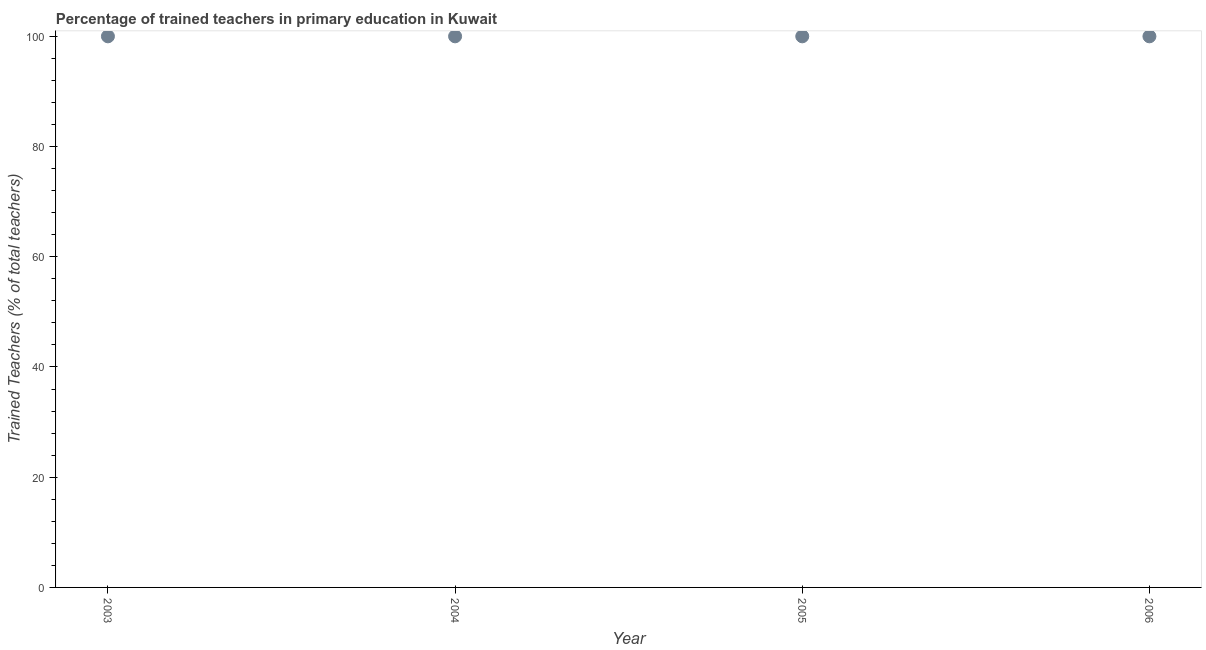Across all years, what is the minimum percentage of trained teachers?
Your answer should be very brief. 100. In which year was the percentage of trained teachers maximum?
Offer a very short reply. 2003. What is the average percentage of trained teachers per year?
Give a very brief answer. 100. What is the median percentage of trained teachers?
Offer a very short reply. 100. Do a majority of the years between 2006 and 2003 (inclusive) have percentage of trained teachers greater than 4 %?
Make the answer very short. Yes. Is the difference between the percentage of trained teachers in 2003 and 2006 greater than the difference between any two years?
Your answer should be compact. Yes. Is the sum of the percentage of trained teachers in 2003 and 2004 greater than the maximum percentage of trained teachers across all years?
Your response must be concise. Yes. How many years are there in the graph?
Your answer should be very brief. 4. What is the difference between two consecutive major ticks on the Y-axis?
Your answer should be very brief. 20. Does the graph contain grids?
Ensure brevity in your answer.  No. What is the title of the graph?
Your response must be concise. Percentage of trained teachers in primary education in Kuwait. What is the label or title of the X-axis?
Keep it short and to the point. Year. What is the label or title of the Y-axis?
Make the answer very short. Trained Teachers (% of total teachers). What is the Trained Teachers (% of total teachers) in 2003?
Your response must be concise. 100. What is the Trained Teachers (% of total teachers) in 2004?
Your answer should be very brief. 100. What is the Trained Teachers (% of total teachers) in 2006?
Your answer should be compact. 100. What is the difference between the Trained Teachers (% of total teachers) in 2005 and 2006?
Ensure brevity in your answer.  0. What is the ratio of the Trained Teachers (% of total teachers) in 2003 to that in 2004?
Ensure brevity in your answer.  1. What is the ratio of the Trained Teachers (% of total teachers) in 2003 to that in 2005?
Provide a succinct answer. 1. What is the ratio of the Trained Teachers (% of total teachers) in 2004 to that in 2005?
Make the answer very short. 1. What is the ratio of the Trained Teachers (% of total teachers) in 2004 to that in 2006?
Your answer should be compact. 1. 